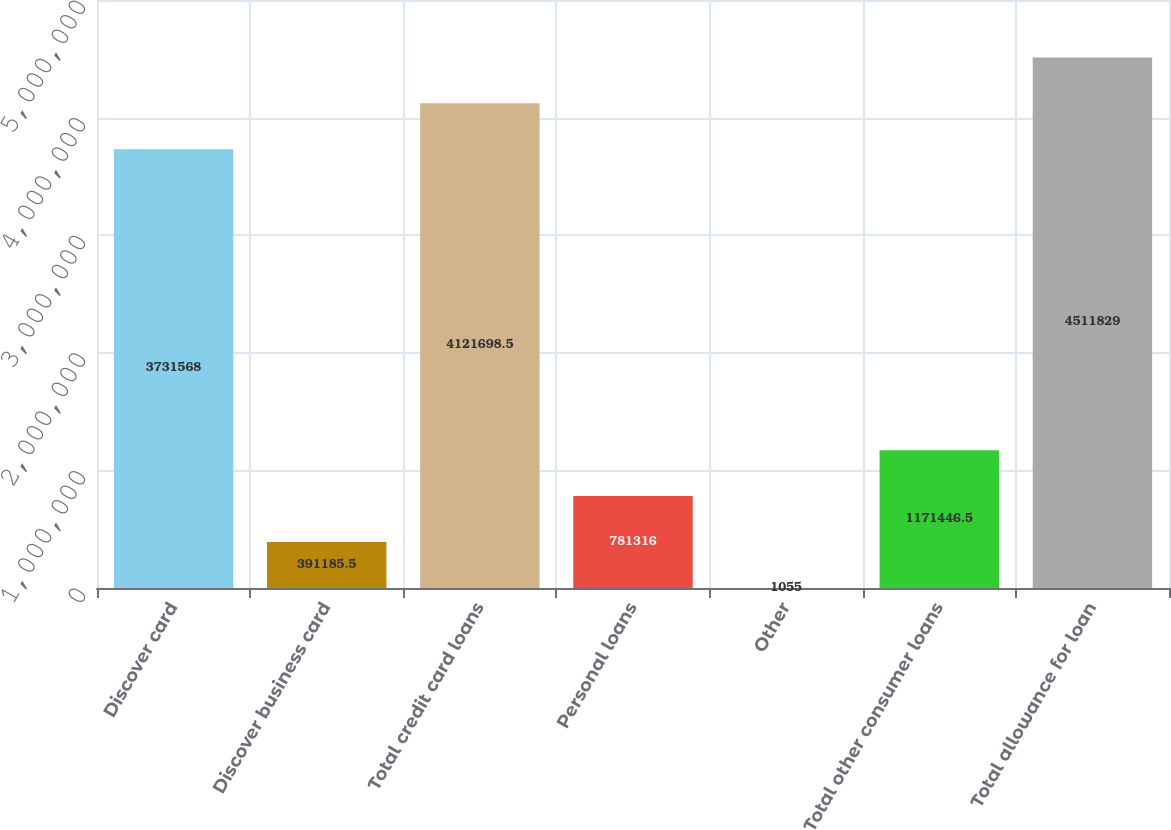<chart> <loc_0><loc_0><loc_500><loc_500><bar_chart><fcel>Discover card<fcel>Discover business card<fcel>Total credit card loans<fcel>Personal loans<fcel>Other<fcel>Total other consumer loans<fcel>Total allowance for loan<nl><fcel>3.73157e+06<fcel>391186<fcel>4.1217e+06<fcel>781316<fcel>1055<fcel>1.17145e+06<fcel>4.51183e+06<nl></chart> 